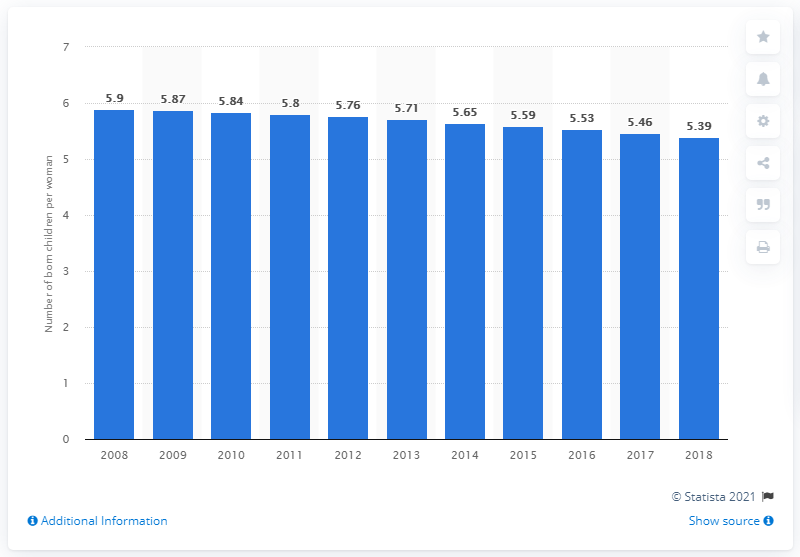Give some essential details in this illustration. In 2018, the fertility rate in Nigeria was 5.39. 